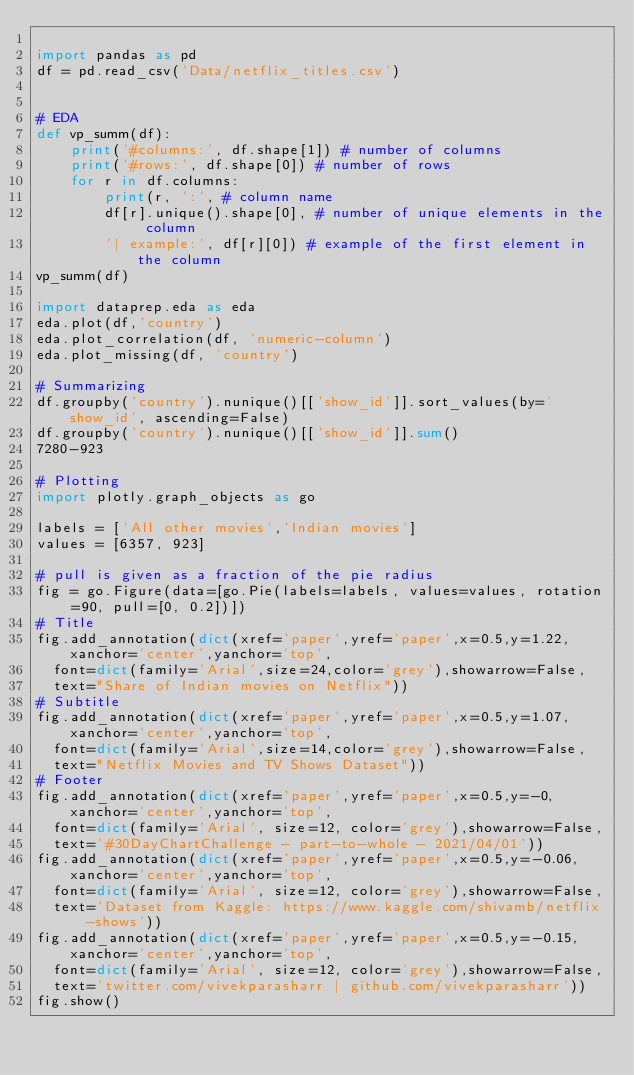Convert code to text. <code><loc_0><loc_0><loc_500><loc_500><_Python_>
import pandas as pd
df = pd.read_csv('Data/netflix_titles.csv')


# EDA
def vp_summ(df):
    print('#columns:', df.shape[1]) # number of columns
    print('#rows:', df.shape[0]) # number of rows
    for r in df.columns:
        print(r, ':', # column name
        df[r].unique().shape[0], # number of unique elements in the column
        '| example:', df[r][0]) # example of the first element in the column
vp_summ(df)

import dataprep.eda as eda
eda.plot(df,'country')
eda.plot_correlation(df, 'numeric-column') 
eda.plot_missing(df, 'country')

# Summarizing
df.groupby('country').nunique()[['show_id']].sort_values(by='show_id', ascending=False)
df.groupby('country').nunique()[['show_id']].sum()
7280-923

# Plotting
import plotly.graph_objects as go

labels = ['All other movies','Indian movies']
values = [6357, 923]

# pull is given as a fraction of the pie radius
fig = go.Figure(data=[go.Pie(labels=labels, values=values, rotation=90, pull=[0, 0.2])])
# Title
fig.add_annotation(dict(xref='paper',yref='paper',x=0.5,y=1.22,xanchor='center',yanchor='top', 
  font=dict(family='Arial',size=24,color='grey'),showarrow=False, 
  text="Share of Indian movies on Netflix"))
# Subtitle
fig.add_annotation(dict(xref='paper',yref='paper',x=0.5,y=1.07,xanchor='center',yanchor='top',
  font=dict(family='Arial',size=14,color='grey'),showarrow=False,
  text="Netflix Movies and TV Shows Dataset"))
# Footer
fig.add_annotation(dict(xref='paper',yref='paper',x=0.5,y=-0,xanchor='center',yanchor='top',
  font=dict(family='Arial', size=12, color='grey'),showarrow=False,
  text='#30DayChartChallenge - part-to-whole - 2021/04/01'))
fig.add_annotation(dict(xref='paper',yref='paper',x=0.5,y=-0.06,xanchor='center',yanchor='top',
  font=dict(family='Arial', size=12, color='grey'),showarrow=False,
  text='Dataset from Kaggle: https://www.kaggle.com/shivamb/netflix-shows'))
fig.add_annotation(dict(xref='paper',yref='paper',x=0.5,y=-0.15,xanchor='center',yanchor='top',
  font=dict(family='Arial', size=12, color='grey'),showarrow=False,
  text='twitter.com/vivekparasharr | github.com/vivekparasharr'))
fig.show()


</code> 